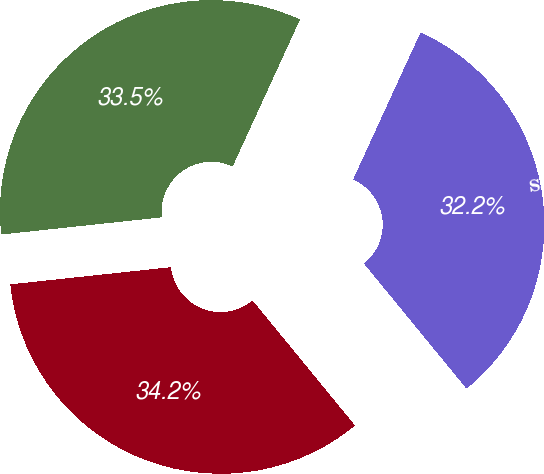<chart> <loc_0><loc_0><loc_500><loc_500><pie_chart><fcel>Zions Bancorporation<fcel>KBW Bank Index<fcel>S&P 500<nl><fcel>34.23%<fcel>33.54%<fcel>32.23%<nl></chart> 